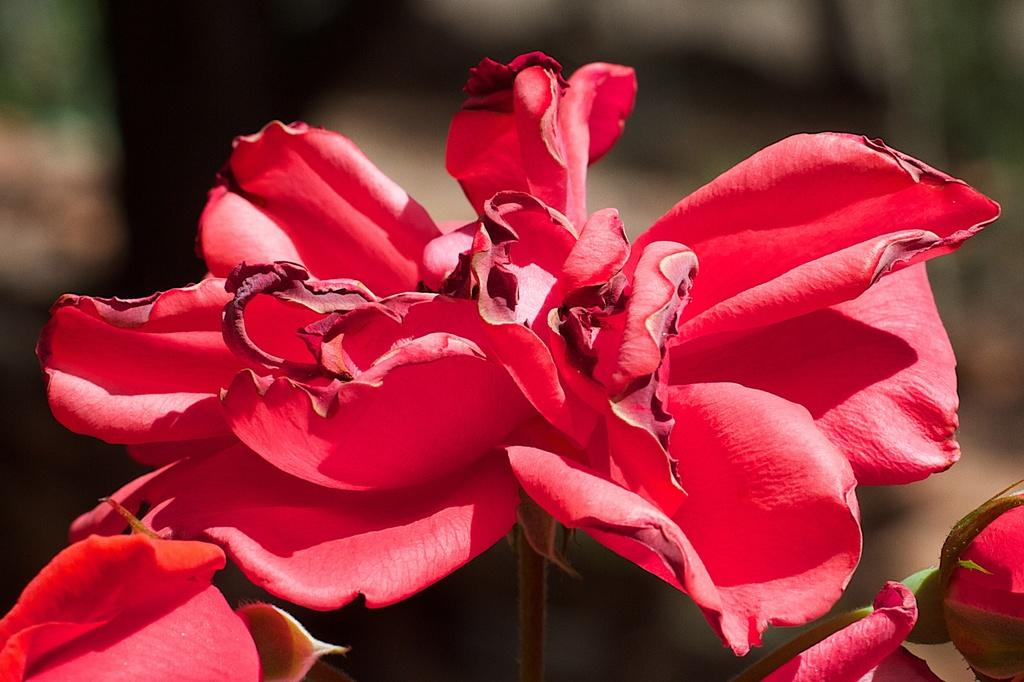What type of flowers can be seen in the image? There are red color flowers in the image. Can you describe the background of the image? The background of the image is blurred. What type of beetle can be seen crawling on the flowers in the image? There is no beetle present in the image; it only features red color flowers. 